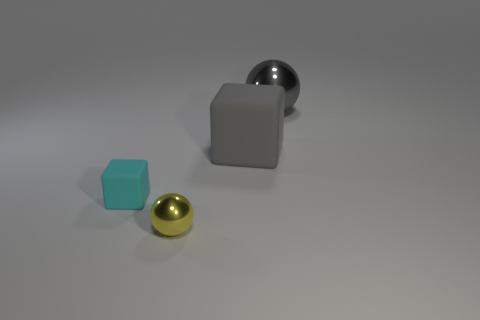Add 4 big gray spheres. How many objects exist? 8 Add 1 yellow metallic objects. How many yellow metallic objects are left? 2 Add 1 tiny yellow blocks. How many tiny yellow blocks exist? 1 Subtract 0 blue cubes. How many objects are left? 4 Subtract all small red metallic things. Subtract all yellow metal balls. How many objects are left? 3 